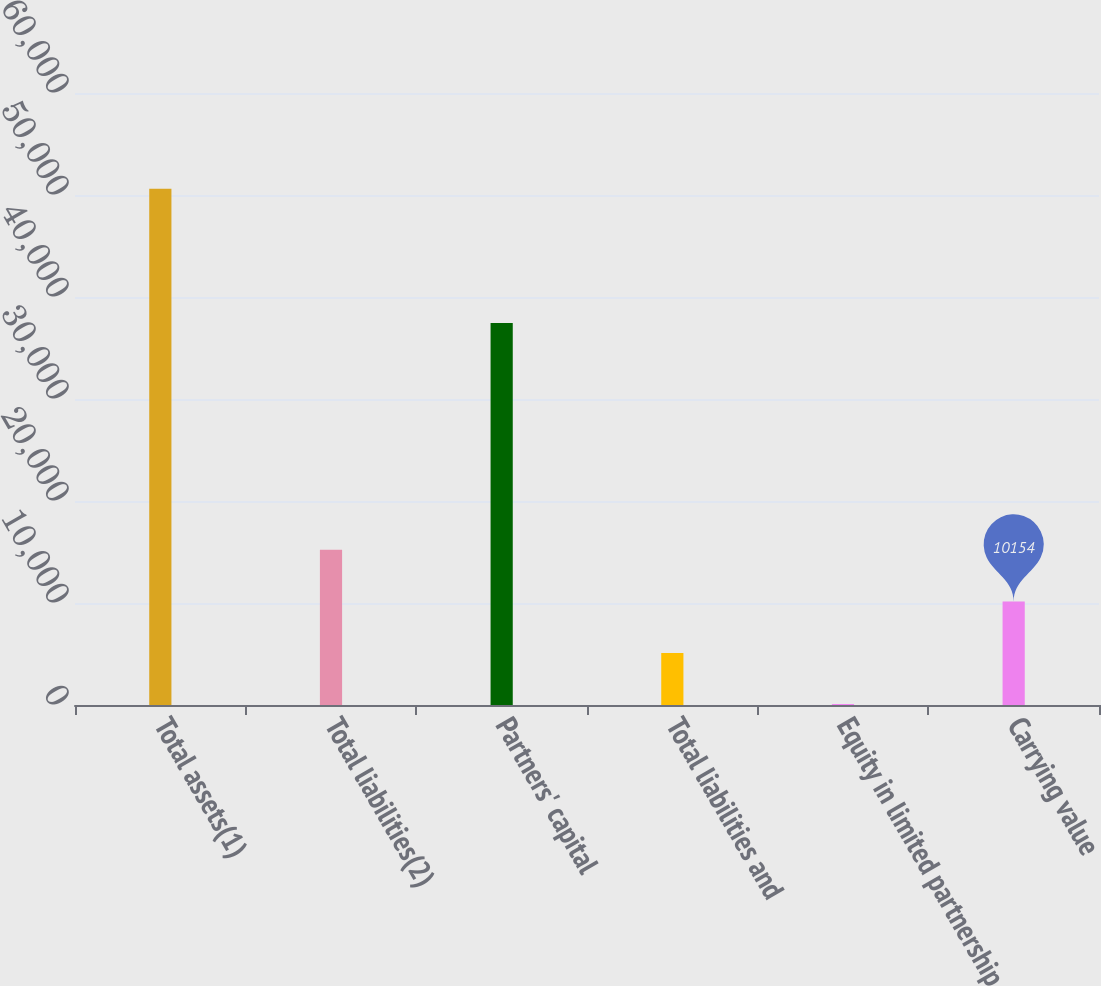<chart> <loc_0><loc_0><loc_500><loc_500><bar_chart><fcel>Total assets(1)<fcel>Total liabilities(2)<fcel>Partners' capital<fcel>Total liabilities and<fcel>Equity in limited partnership<fcel>Carrying value<nl><fcel>50602<fcel>15210<fcel>37450<fcel>5098<fcel>42<fcel>10154<nl></chart> 